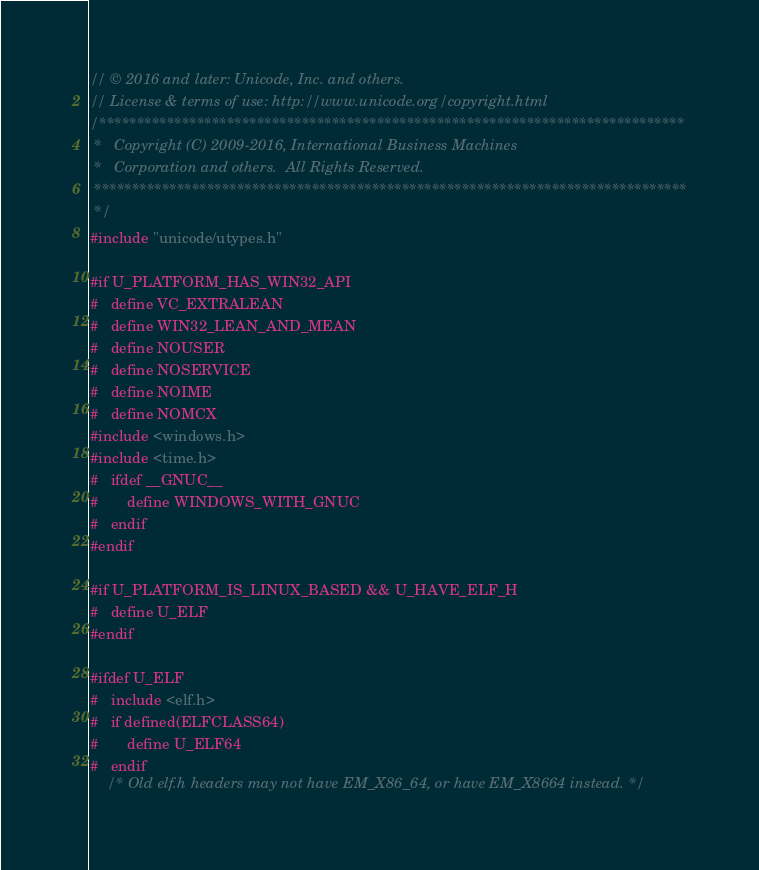Convert code to text. <code><loc_0><loc_0><loc_500><loc_500><_C++_>// © 2016 and later: Unicode, Inc. and others.
// License & terms of use: http://www.unicode.org/copyright.html
/******************************************************************************
 *   Copyright (C) 2009-2016, International Business Machines
 *   Corporation and others.  All Rights Reserved.
 *******************************************************************************
 */
#include "unicode/utypes.h"

#if U_PLATFORM_HAS_WIN32_API
#   define VC_EXTRALEAN
#   define WIN32_LEAN_AND_MEAN
#   define NOUSER
#   define NOSERVICE
#   define NOIME
#   define NOMCX
#include <windows.h>
#include <time.h>
#   ifdef __GNUC__
#       define WINDOWS_WITH_GNUC
#   endif
#endif

#if U_PLATFORM_IS_LINUX_BASED && U_HAVE_ELF_H
#   define U_ELF
#endif

#ifdef U_ELF
#   include <elf.h>
#   if defined(ELFCLASS64)
#       define U_ELF64
#   endif
    /* Old elf.h headers may not have EM_X86_64, or have EM_X8664 instead. */</code> 